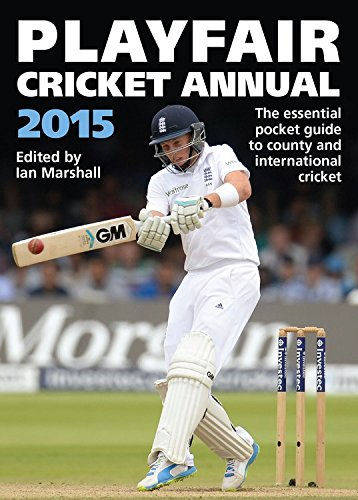What is the genre of this book? This book falls under the 'Sports & Outdoors' category, specifically focusing on the sport of cricket. 